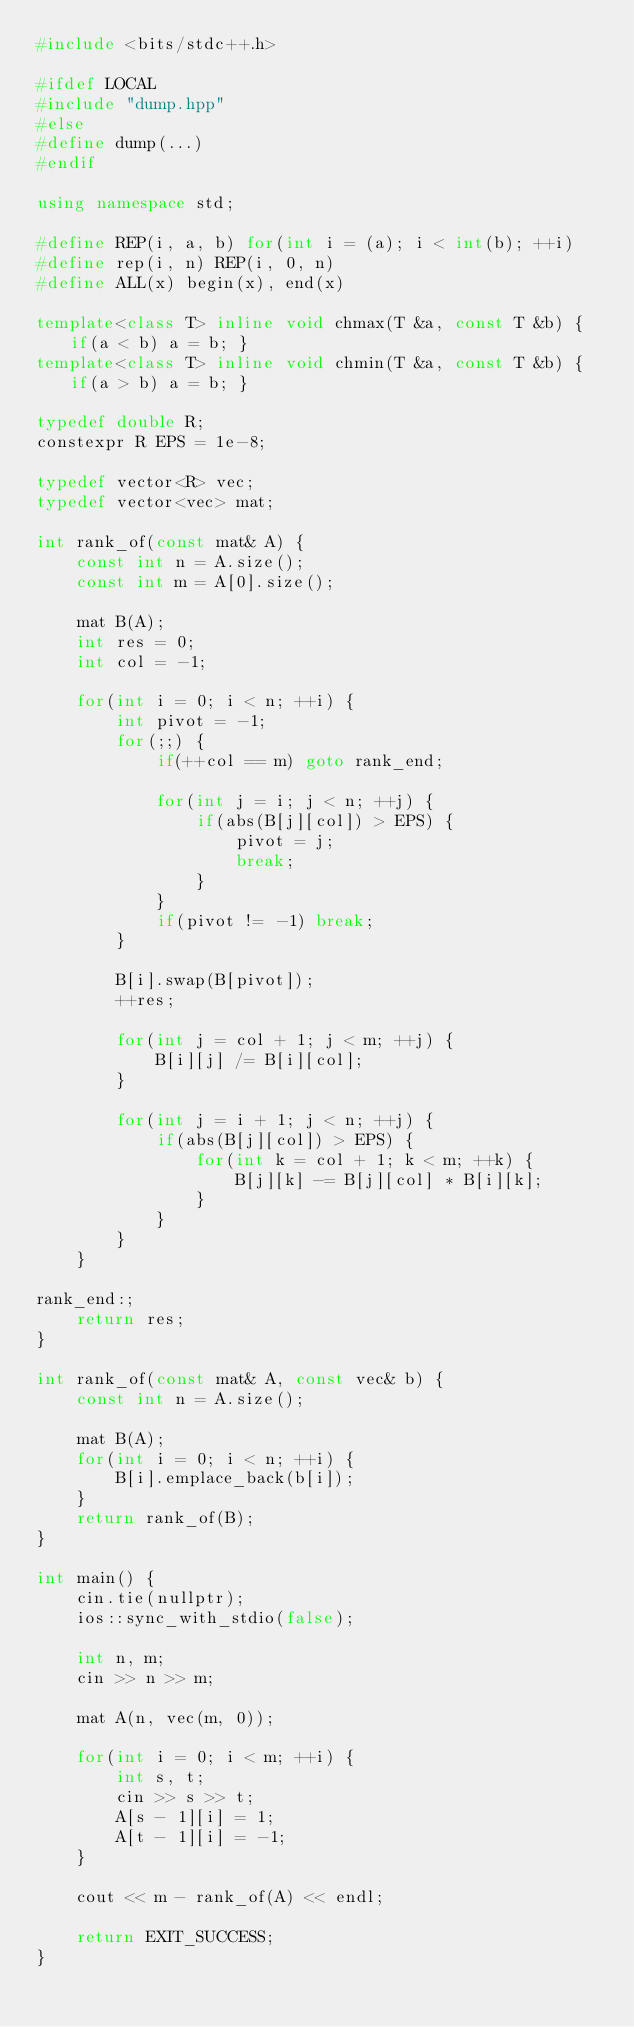Convert code to text. <code><loc_0><loc_0><loc_500><loc_500><_C++_>#include <bits/stdc++.h>

#ifdef LOCAL
#include "dump.hpp"
#else
#define dump(...)
#endif

using namespace std;

#define REP(i, a, b) for(int i = (a); i < int(b); ++i)
#define rep(i, n) REP(i, 0, n)
#define ALL(x) begin(x), end(x)

template<class T> inline void chmax(T &a, const T &b) { if(a < b) a = b; }
template<class T> inline void chmin(T &a, const T &b) { if(a > b) a = b; }

typedef double R;
constexpr R EPS = 1e-8;

typedef vector<R> vec;
typedef vector<vec> mat;

int rank_of(const mat& A) {
	const int n = A.size();
	const int m = A[0].size();

	mat B(A);
	int res = 0;
	int col = -1;

	for(int i = 0; i < n; ++i) {
		int pivot = -1;
		for(;;) {
			if(++col == m) goto rank_end;

			for(int j = i; j < n; ++j) {
				if(abs(B[j][col]) > EPS) {
					pivot = j;
					break;
				}
			}
			if(pivot != -1) break;
		}

		B[i].swap(B[pivot]);
		++res;

		for(int j = col + 1; j < m; ++j) {
			B[i][j] /= B[i][col];
		}

		for(int j = i + 1; j < n; ++j) {
			if(abs(B[j][col]) > EPS) {
				for(int k = col + 1; k < m; ++k) {
					B[j][k] -= B[j][col] * B[i][k];
				}
			}
		}
	}

rank_end:;
	return res;
}

int rank_of(const mat& A, const vec& b) {
	const int n = A.size();

	mat B(A);
	for(int i = 0; i < n; ++i) {
		B[i].emplace_back(b[i]);
	}
	return rank_of(B);
}

int main() {
	cin.tie(nullptr);
	ios::sync_with_stdio(false);

	int n, m;
	cin >> n >> m;

	mat A(n, vec(m, 0));

	for(int i = 0; i < m; ++i) {
		int s, t;
		cin >> s >> t;
		A[s - 1][i] = 1;
		A[t - 1][i] = -1;
	}

	cout << m - rank_of(A) << endl;

	return EXIT_SUCCESS;
}</code> 